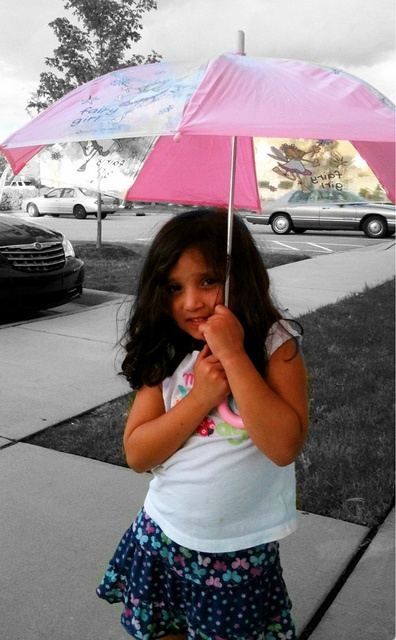Describe the objects in this image and their specific colors. I can see people in lightgray, black, darkgray, brown, and maroon tones, umbrella in lightgray, lavender, pink, violet, and darkgray tones, car in lightgray, black, gray, and darkgray tones, car in lightgray, darkgray, black, and gray tones, and car in lightgray, darkgray, black, and gray tones in this image. 